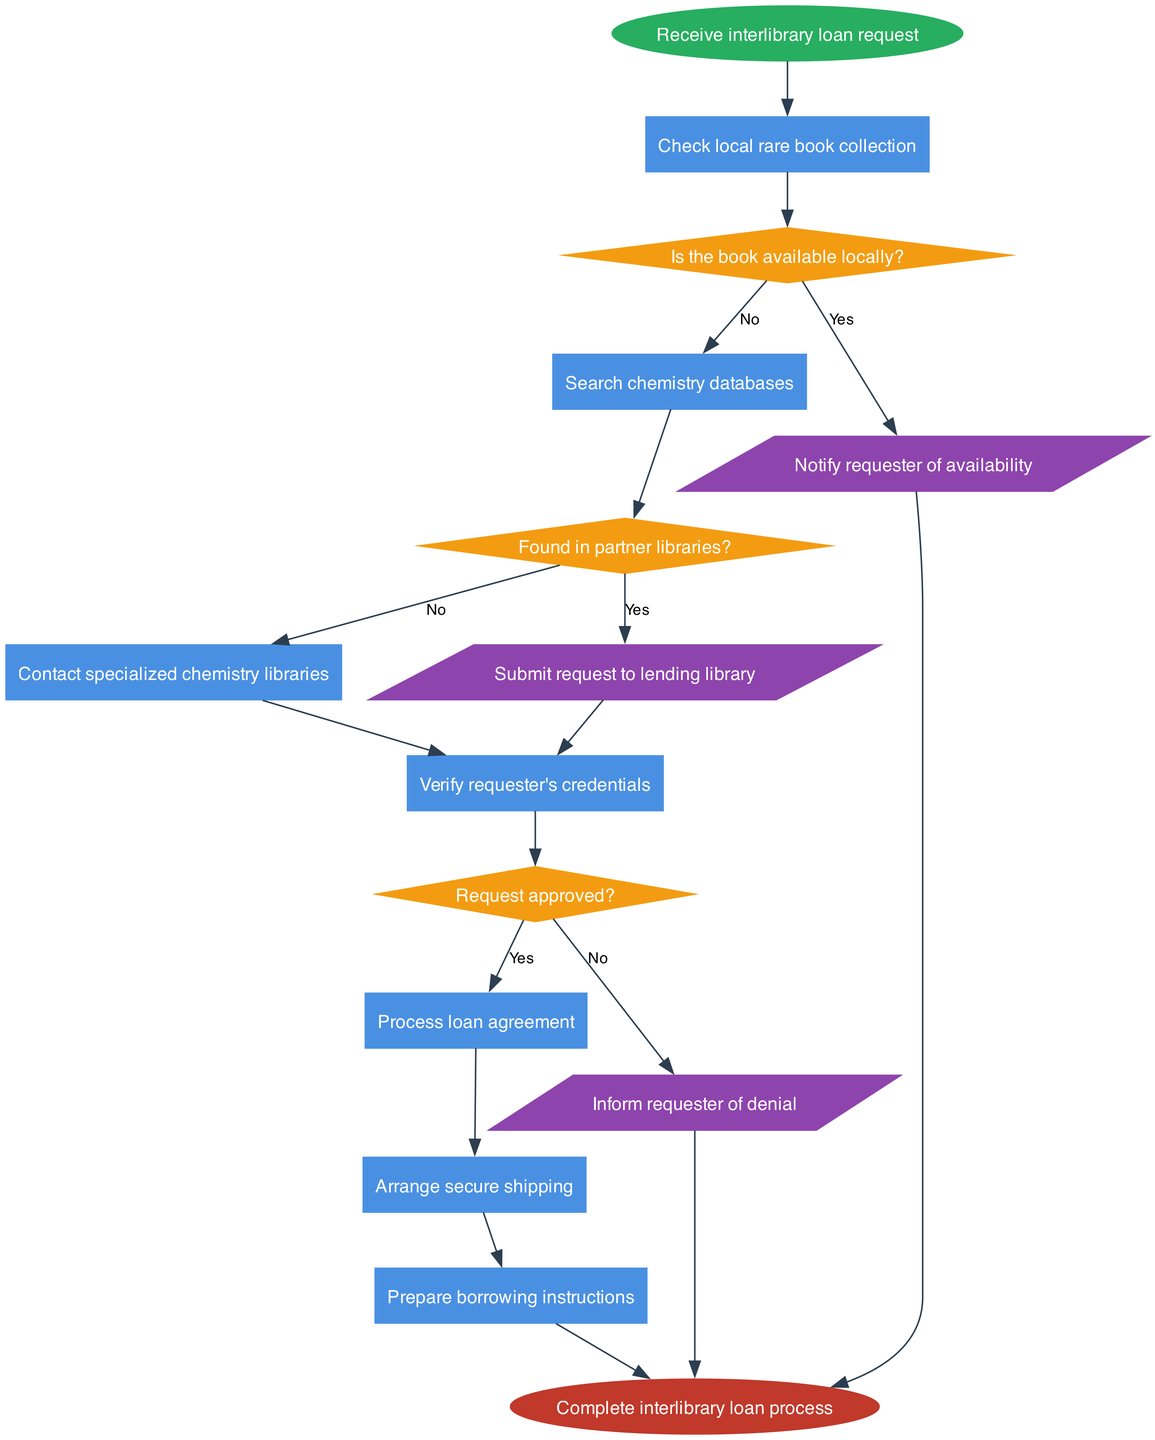What is the initial step in the interlibrary loan process? The initial step, as represented by the start node, is to receive the interlibrary loan request. This is the first action that sets the process in motion.
Answer: Receive interlibrary loan request How many nodes are there in the diagram? The diagram contains a total of 8 nodes: 1 start node, 6 process nodes, and 1 end node. Each node represents a step or decision point in the interlibrary loan process.
Answer: 8 What do you do if the book is available locally? If the book is available locally, the process proceeds to the action of notifying the requester of availability. This decision leads directly to informing the requester without needing further steps.
Answer: Notify requester of availability What happens if the book is not found in partner libraries? If the book is not found in partner libraries, the process leads to verifying the requester's credentials. This signifies that the search must continue to ensure that the request is legitimate before further actions are taken.
Answer: Verify requester's credentials What action follows after approving the request? After the request is approved, the next action is to process the loan agreement. This step is crucial as it formalizes the arrangement before further steps, such as shipping and preparing instructions, can occur.
Answer: Process loan agreement How many decisions are made during the interlibrary loan process? There are 3 decision points in the process: checking local availability, searching partner libraries, and getting request approval. Each decision influences the flow of actions in the diagram.
Answer: 3 What is the final outcome of the interlibrary loan process? The final outcome, as shown in the end node, is the completion of the interlibrary loan process. This indicates that all steps and actions have been executed to fulfil the loan request successfully.
Answer: Complete interlibrary loan process What do you do if the request is denied? If the request is denied, the corresponding action is to inform the requester of the denial. This step ensures that the requester is aware of the outcome and can adjust their expectations.
Answer: Inform requester of denial What step occurs after preparing borrowing instructions? The step following the preparation of borrowing instructions is the completion of the interlibrary loan process. This indicates that everything is now finalized and ready for the requester.
Answer: Complete interlibrary loan process 